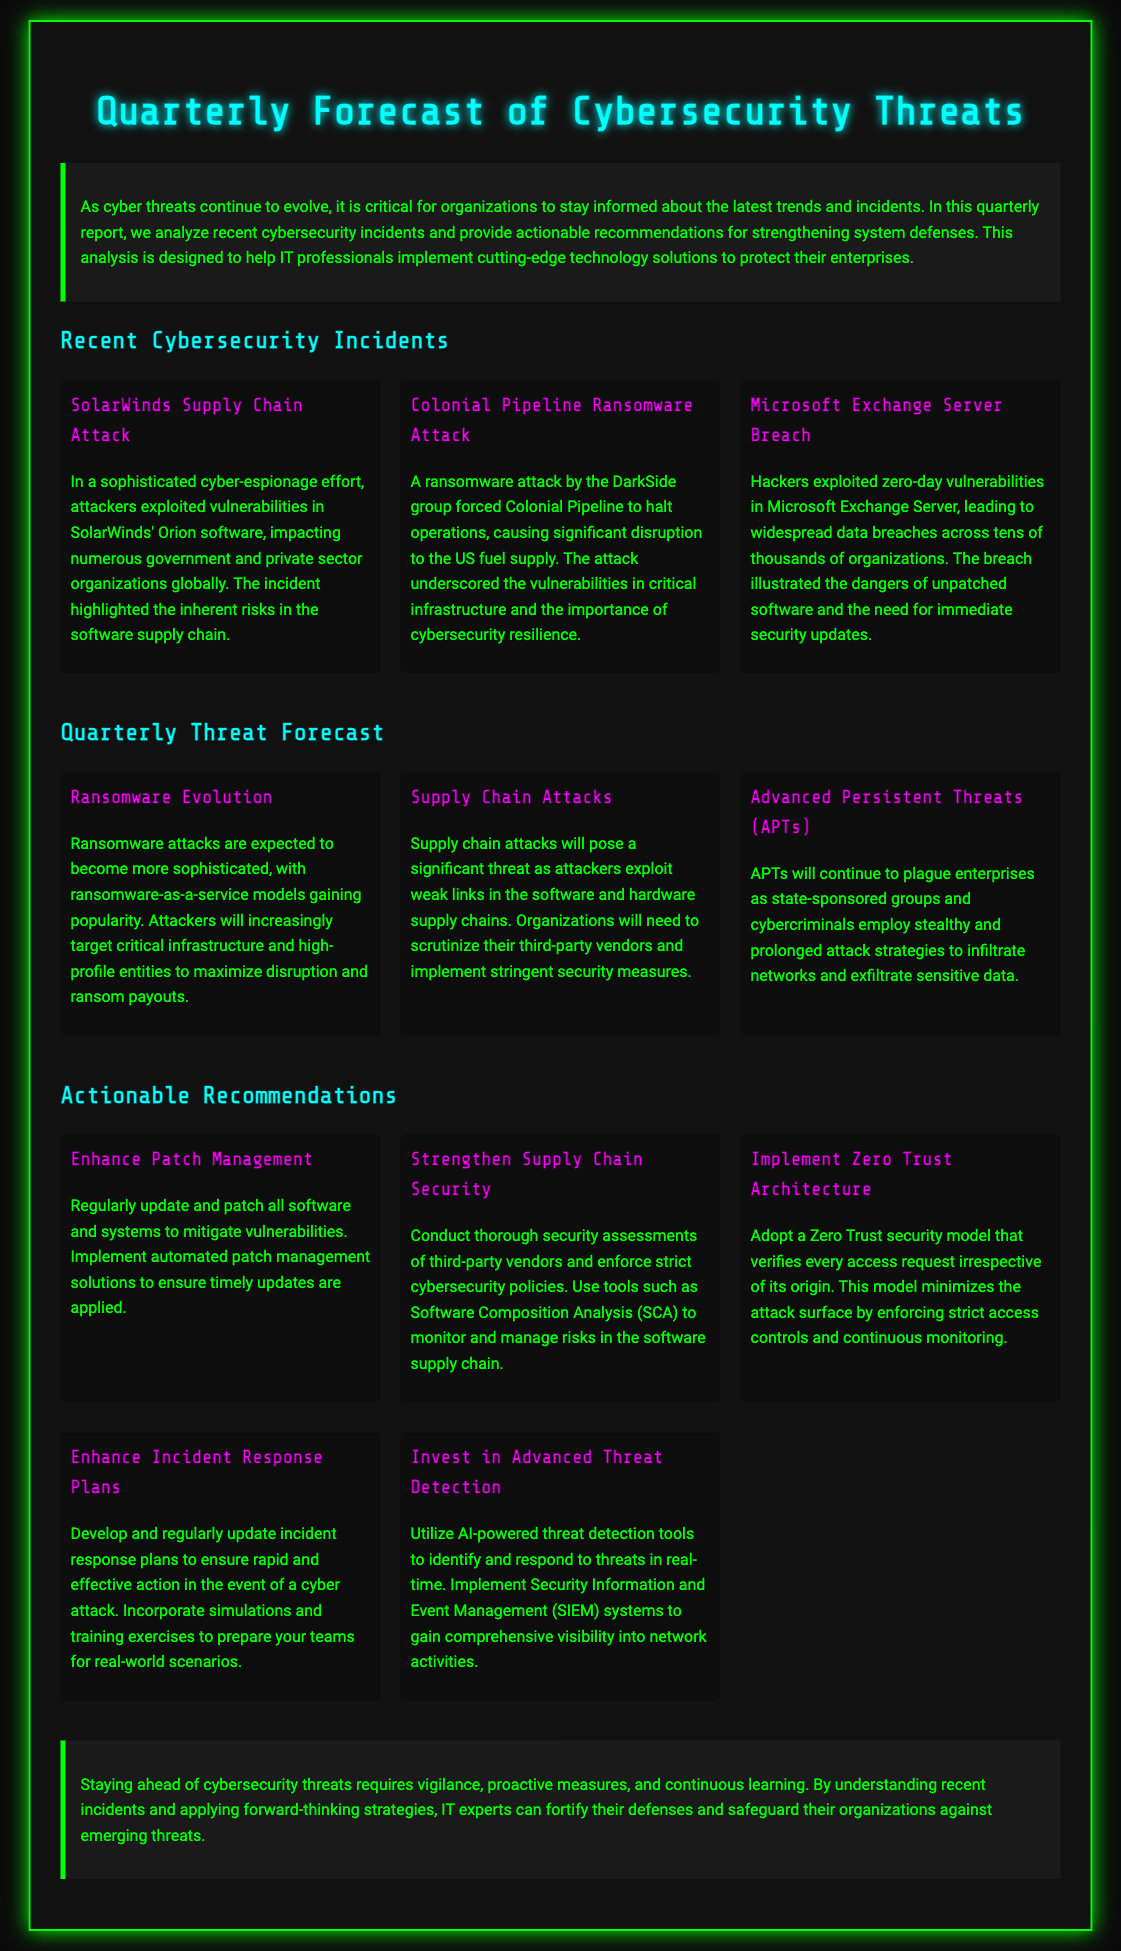What is the title of the document? The title of the document is indicated in the header section of the Playbill.
Answer: Quarterly Forecast of Cybersecurity Threats How many recent cybersecurity incidents are listed? The document lists three specific recent incidents in the corresponding section.
Answer: Three What attack highlighted risks in the software supply chain? This incident is one among those discussed in the section on recent incidents.
Answer: SolarWinds Supply Chain Attack Which cybersecurity model is recommended for access requests? The provided recommendations detail various strategies, including a specific security model.
Answer: Zero Trust Architecture What is expected to evolve according to the quarterly threat forecast? The threat forecast provides insights into various types of threats expected in the coming period.
Answer: Ransomware Evolution How often should software updates be applied? The recommendations discuss a specific approach towards maintaining software systems.
Answer: Regularly What tool is suggested for monitoring risks in the software supply chain? The recommendations include a specific tool aimed at enhancing supply chain security.
Answer: Software Composition Analysis What is the overall goal of enhancing incident response plans? The actionable recommendations describe the primary purpose of updating these plans.
Answer: Rapid action Which group was responsible for the ransomware attack on Colonial Pipeline? The document identifies the group associated with this cybersecurity incident.
Answer: DarkSide 